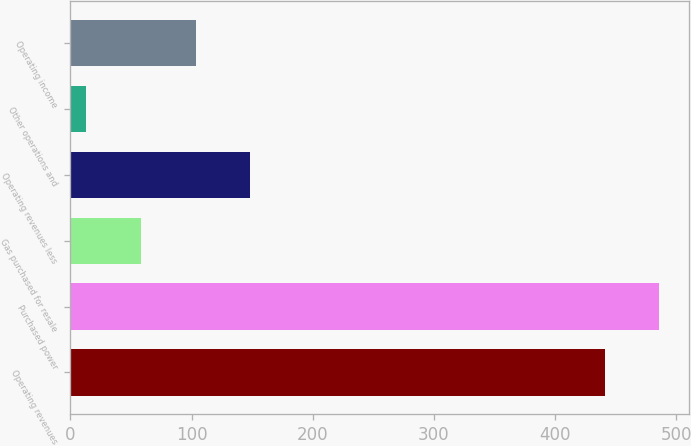Convert chart to OTSL. <chart><loc_0><loc_0><loc_500><loc_500><bar_chart><fcel>Operating revenues<fcel>Purchased power<fcel>Gas purchased for resale<fcel>Operating revenues less<fcel>Other operations and<fcel>Operating income<nl><fcel>441<fcel>486.2<fcel>58.2<fcel>148.6<fcel>13<fcel>103.4<nl></chart> 